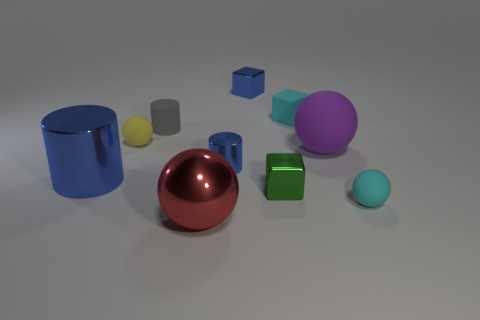Subtract all green cubes. How many cubes are left? 2 Subtract all red balls. How many blue cylinders are left? 2 Subtract all red spheres. How many spheres are left? 3 Subtract all balls. How many objects are left? 6 Subtract 2 spheres. How many spheres are left? 2 Subtract all brown spheres. Subtract all purple blocks. How many spheres are left? 4 Subtract all large rubber spheres. Subtract all green cubes. How many objects are left? 8 Add 2 shiny balls. How many shiny balls are left? 3 Add 2 tiny brown rubber cylinders. How many tiny brown rubber cylinders exist? 2 Subtract 1 cyan blocks. How many objects are left? 9 